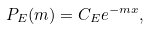Convert formula to latex. <formula><loc_0><loc_0><loc_500><loc_500>P _ { E } ( m ) = C _ { E } e ^ { - m x } ,</formula> 